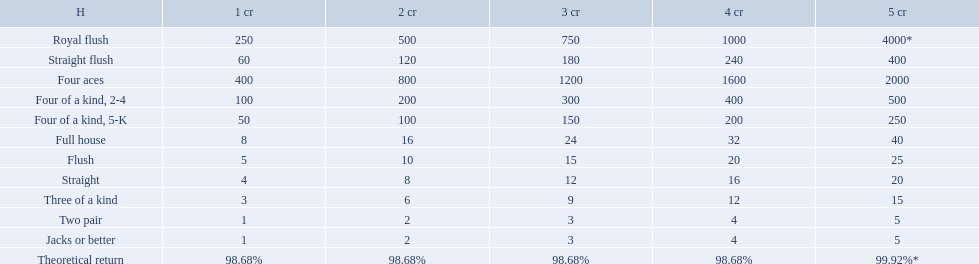What are the hands in super aces? Royal flush, Straight flush, Four aces, Four of a kind, 2-4, Four of a kind, 5-K, Full house, Flush, Straight, Three of a kind, Two pair, Jacks or better. What hand gives the highest credits? Royal flush. Which hand is the third best hand in the card game super aces? Four aces. Which hand is the second best hand? Straight flush. Which hand had is the best hand? Royal flush. What is the higher amount of points for one credit you can get from the best four of a kind 100. What type is it? Four of a kind, 2-4. Parse the full table. {'header': ['H', '1 cr', '2 cr', '3 cr', '4 cr', '5 cr'], 'rows': [['Royal flush', '250', '500', '750', '1000', '4000*'], ['Straight flush', '60', '120', '180', '240', '400'], ['Four aces', '400', '800', '1200', '1600', '2000'], ['Four of a kind, 2-4', '100', '200', '300', '400', '500'], ['Four of a kind, 5-K', '50', '100', '150', '200', '250'], ['Full house', '8', '16', '24', '32', '40'], ['Flush', '5', '10', '15', '20', '25'], ['Straight', '4', '8', '12', '16', '20'], ['Three of a kind', '3', '6', '9', '12', '15'], ['Two pair', '1', '2', '3', '4', '5'], ['Jacks or better', '1', '2', '3', '4', '5'], ['Theoretical return', '98.68%', '98.68%', '98.68%', '98.68%', '99.92%*']]} Which hand is lower than straight flush? Four aces. Which hand is lower than four aces? Four of a kind, 2-4. Which hand is higher out of straight and flush? Flush. What are each of the hands? Royal flush, Straight flush, Four aces, Four of a kind, 2-4, Four of a kind, 5-K, Full house, Flush, Straight, Three of a kind, Two pair, Jacks or better, Theoretical return. Which hand ranks higher between straights and flushes? Flush. What are the different hands? Royal flush, Straight flush, Four aces, Four of a kind, 2-4, Four of a kind, 5-K, Full house, Flush, Straight, Three of a kind, Two pair, Jacks or better. Which hands have a higher standing than a straight? Royal flush, Straight flush, Four aces, Four of a kind, 2-4, Four of a kind, 5-K, Full house, Flush. Of these, which hand is the next highest after a straight? Flush. 